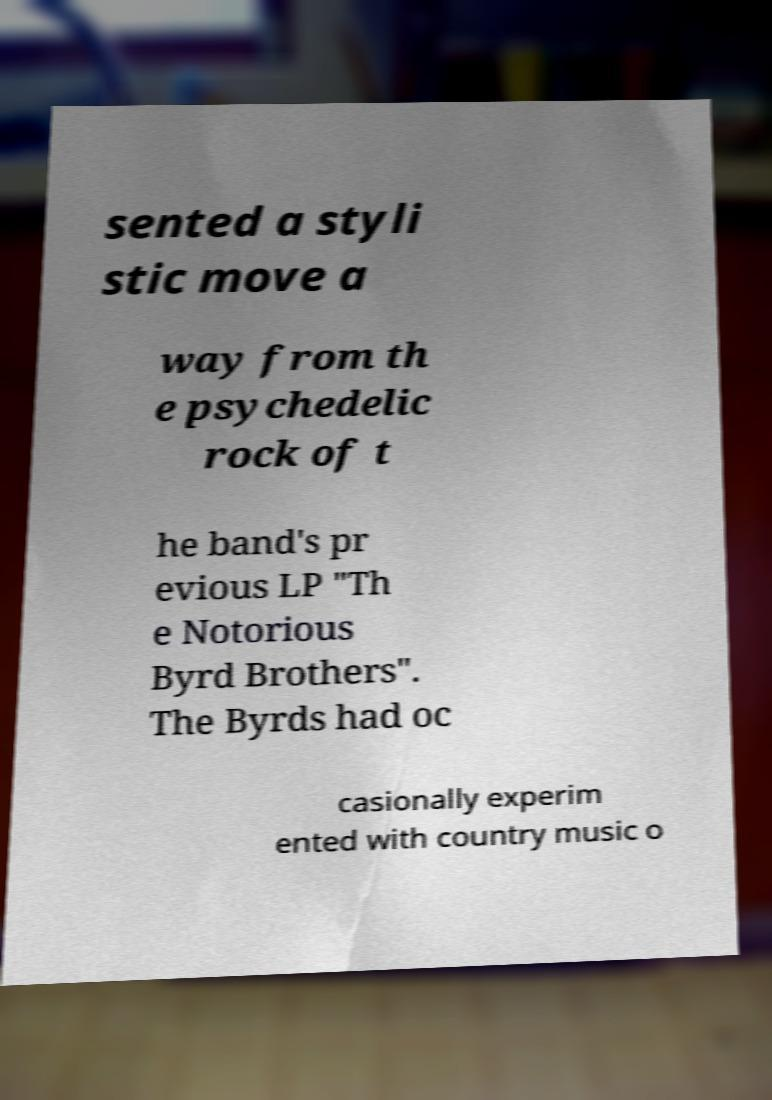For documentation purposes, I need the text within this image transcribed. Could you provide that? sented a styli stic move a way from th e psychedelic rock of t he band's pr evious LP "Th e Notorious Byrd Brothers". The Byrds had oc casionally experim ented with country music o 